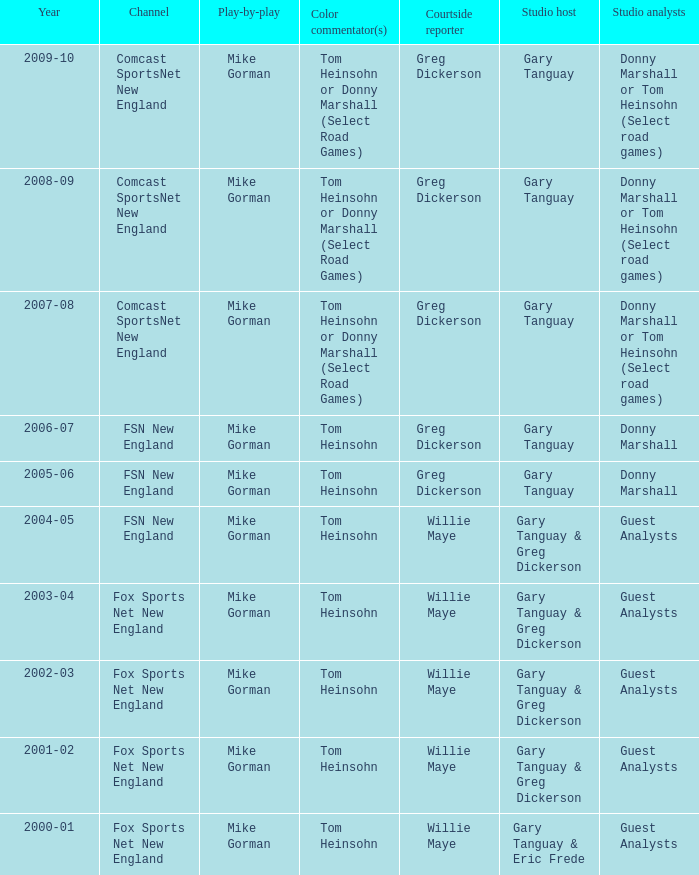WHich Color commentatorhas a Studio host of gary tanguay & eric frede? Tom Heinsohn. 